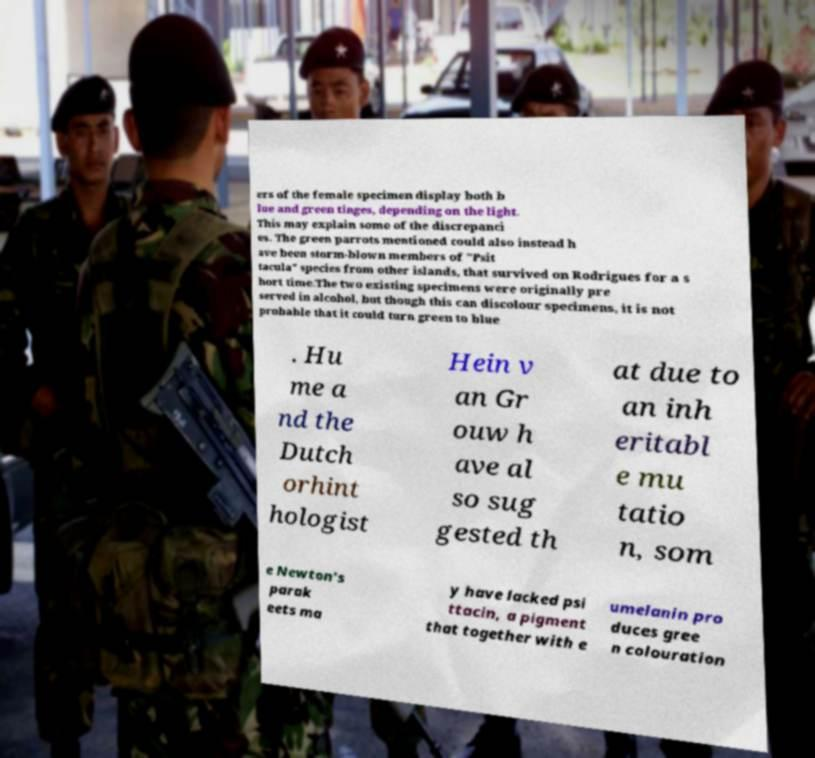Can you accurately transcribe the text from the provided image for me? ers of the female specimen display both b lue and green tinges, depending on the light. This may explain some of the discrepanci es. The green parrots mentioned could also instead h ave been storm-blown members of "Psit tacula" species from other islands, that survived on Rodrigues for a s hort time.The two existing specimens were originally pre served in alcohol, but though this can discolour specimens, it is not probable that it could turn green to blue . Hu me a nd the Dutch orhint hologist Hein v an Gr ouw h ave al so sug gested th at due to an inh eritabl e mu tatio n, som e Newton's parak eets ma y have lacked psi ttacin, a pigment that together with e umelanin pro duces gree n colouration 